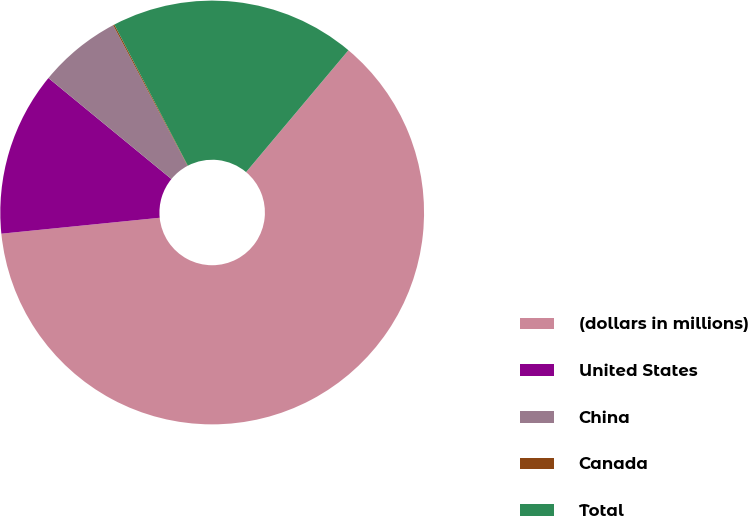Convert chart to OTSL. <chart><loc_0><loc_0><loc_500><loc_500><pie_chart><fcel>(dollars in millions)<fcel>United States<fcel>China<fcel>Canada<fcel>Total<nl><fcel>62.3%<fcel>12.54%<fcel>6.32%<fcel>0.1%<fcel>18.76%<nl></chart> 